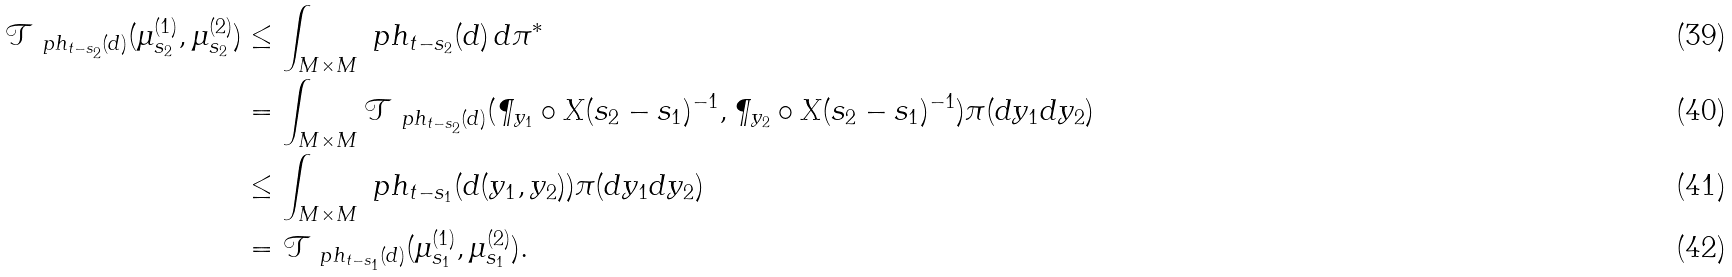<formula> <loc_0><loc_0><loc_500><loc_500>\mathcal { T } _ { \ p h _ { t - s _ { 2 } } ( d ) } ( \mu ^ { ( 1 ) } _ { s _ { 2 } } , \mu ^ { ( 2 ) } _ { s _ { 2 } } ) & \leq \int _ { M \times M } \ p h _ { t - s _ { 2 } } ( d ) \, d \pi ^ { * } \\ & = \int _ { M \times M } \mathcal { T } _ { \ p h _ { t - s _ { 2 } } ( d ) } ( \P _ { y _ { 1 } } \circ X ( s _ { 2 } - s _ { 1 } ) ^ { - 1 } , \P _ { y _ { 2 } } \circ X ( s _ { 2 } - s _ { 1 } ) ^ { - 1 } ) \pi ( d y _ { 1 } d y _ { 2 } ) \\ & \leq \int _ { M \times M } \ p h _ { t - s _ { 1 } } ( d ( y _ { 1 } , y _ { 2 } ) ) \pi ( d y _ { 1 } d y _ { 2 } ) \\ & = \mathcal { T } _ { \ p h _ { t - s _ { 1 } } ( d ) } ( \mu ^ { ( 1 ) } _ { s _ { 1 } } , \mu ^ { ( 2 ) } _ { s _ { 1 } } ) .</formula> 